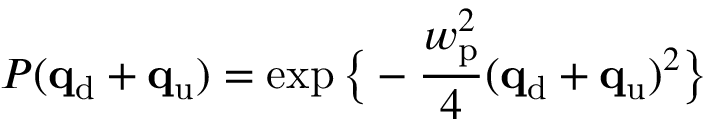<formula> <loc_0><loc_0><loc_500><loc_500>P ( q _ { d } + q _ { u } ) = \exp \left \{ - \frac { w _ { p } ^ { 2 } } { 4 } ( q _ { d } + q _ { u } ) ^ { 2 } \right \}</formula> 